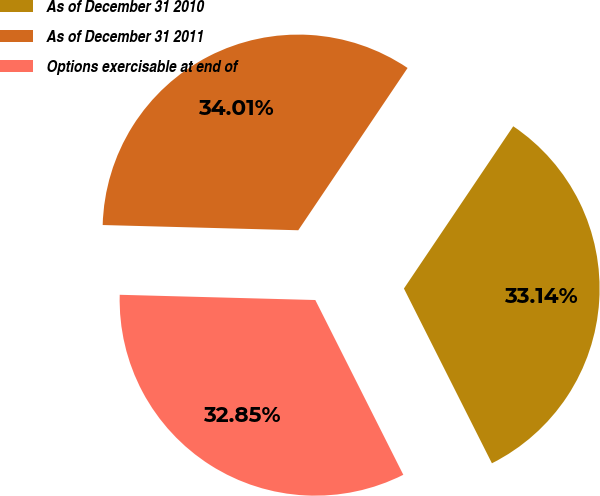Convert chart to OTSL. <chart><loc_0><loc_0><loc_500><loc_500><pie_chart><fcel>As of December 31 2010<fcel>As of December 31 2011<fcel>Options exercisable at end of<nl><fcel>33.14%<fcel>34.01%<fcel>32.85%<nl></chart> 